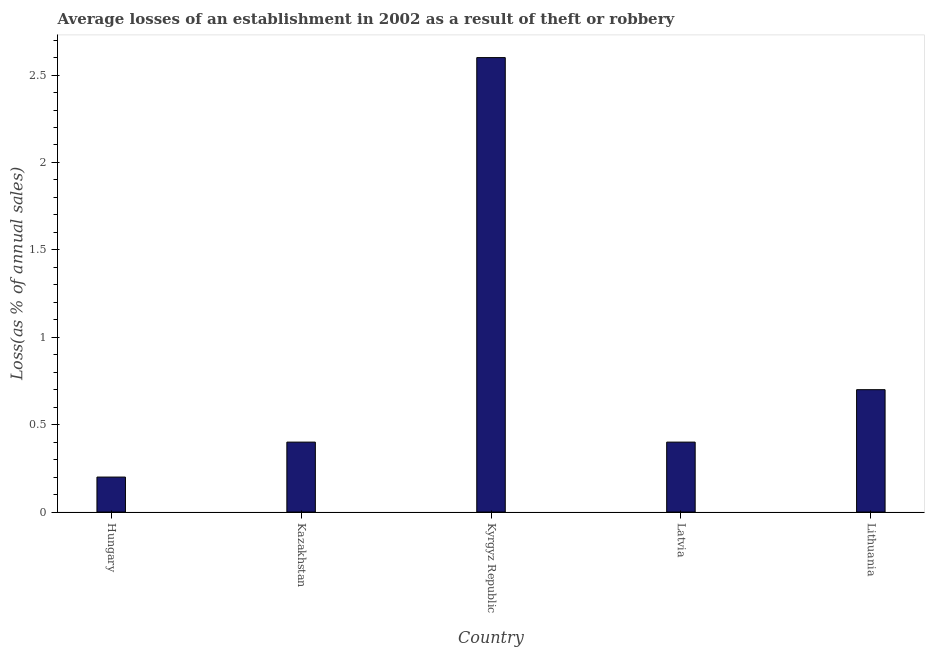Does the graph contain any zero values?
Your answer should be compact. No. What is the title of the graph?
Keep it short and to the point. Average losses of an establishment in 2002 as a result of theft or robbery. What is the label or title of the X-axis?
Offer a terse response. Country. What is the label or title of the Y-axis?
Provide a succinct answer. Loss(as % of annual sales). What is the losses due to theft in Kyrgyz Republic?
Ensure brevity in your answer.  2.6. Across all countries, what is the maximum losses due to theft?
Provide a succinct answer. 2.6. In which country was the losses due to theft maximum?
Your answer should be very brief. Kyrgyz Republic. In which country was the losses due to theft minimum?
Your answer should be compact. Hungary. What is the sum of the losses due to theft?
Ensure brevity in your answer.  4.3. What is the average losses due to theft per country?
Provide a short and direct response. 0.86. What is the median losses due to theft?
Ensure brevity in your answer.  0.4. In how many countries, is the losses due to theft greater than 0.7 %?
Keep it short and to the point. 1. What is the ratio of the losses due to theft in Hungary to that in Kazakhstan?
Keep it short and to the point. 0.5. Is the losses due to theft in Kyrgyz Republic less than that in Lithuania?
Ensure brevity in your answer.  No. What is the difference between the highest and the second highest losses due to theft?
Provide a succinct answer. 1.9. Is the sum of the losses due to theft in Kazakhstan and Kyrgyz Republic greater than the maximum losses due to theft across all countries?
Give a very brief answer. Yes. How many countries are there in the graph?
Ensure brevity in your answer.  5. Are the values on the major ticks of Y-axis written in scientific E-notation?
Your answer should be very brief. No. What is the Loss(as % of annual sales) of Hungary?
Ensure brevity in your answer.  0.2. What is the Loss(as % of annual sales) in Latvia?
Offer a very short reply. 0.4. What is the Loss(as % of annual sales) in Lithuania?
Provide a succinct answer. 0.7. What is the difference between the Loss(as % of annual sales) in Hungary and Latvia?
Your answer should be very brief. -0.2. What is the difference between the Loss(as % of annual sales) in Hungary and Lithuania?
Make the answer very short. -0.5. What is the difference between the Loss(as % of annual sales) in Kyrgyz Republic and Latvia?
Ensure brevity in your answer.  2.2. What is the difference between the Loss(as % of annual sales) in Kyrgyz Republic and Lithuania?
Ensure brevity in your answer.  1.9. What is the difference between the Loss(as % of annual sales) in Latvia and Lithuania?
Keep it short and to the point. -0.3. What is the ratio of the Loss(as % of annual sales) in Hungary to that in Kyrgyz Republic?
Provide a succinct answer. 0.08. What is the ratio of the Loss(as % of annual sales) in Hungary to that in Latvia?
Give a very brief answer. 0.5. What is the ratio of the Loss(as % of annual sales) in Hungary to that in Lithuania?
Ensure brevity in your answer.  0.29. What is the ratio of the Loss(as % of annual sales) in Kazakhstan to that in Kyrgyz Republic?
Give a very brief answer. 0.15. What is the ratio of the Loss(as % of annual sales) in Kazakhstan to that in Lithuania?
Provide a succinct answer. 0.57. What is the ratio of the Loss(as % of annual sales) in Kyrgyz Republic to that in Lithuania?
Offer a very short reply. 3.71. What is the ratio of the Loss(as % of annual sales) in Latvia to that in Lithuania?
Your answer should be compact. 0.57. 